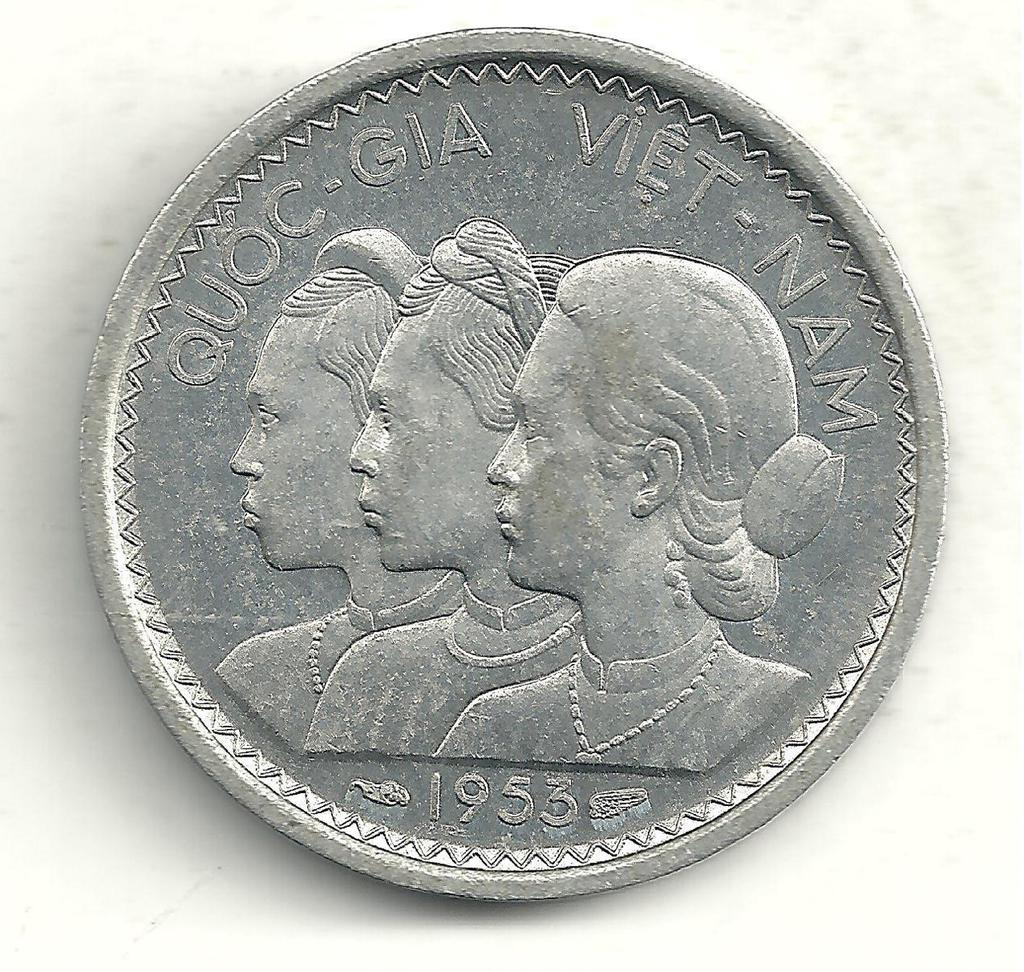<image>
Write a terse but informative summary of the picture. A coin says Quoc-Gia Viet-Name and has the year 1953. 